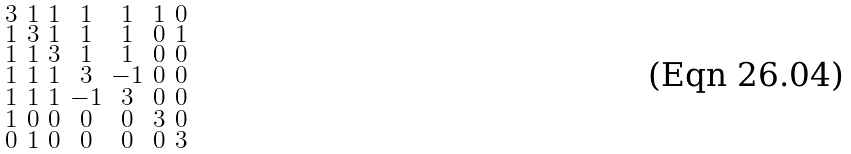Convert formula to latex. <formula><loc_0><loc_0><loc_500><loc_500>\begin{smallmatrix} 3 & 1 & 1 & 1 & 1 & 1 & 0 \\ 1 & 3 & 1 & 1 & 1 & 0 & 1 \\ 1 & 1 & 3 & 1 & 1 & 0 & 0 \\ 1 & 1 & 1 & 3 & - 1 & 0 & 0 \\ 1 & 1 & 1 & - 1 & 3 & 0 & 0 \\ 1 & 0 & 0 & 0 & 0 & 3 & 0 \\ 0 & 1 & 0 & 0 & 0 & 0 & 3 \end{smallmatrix}</formula> 